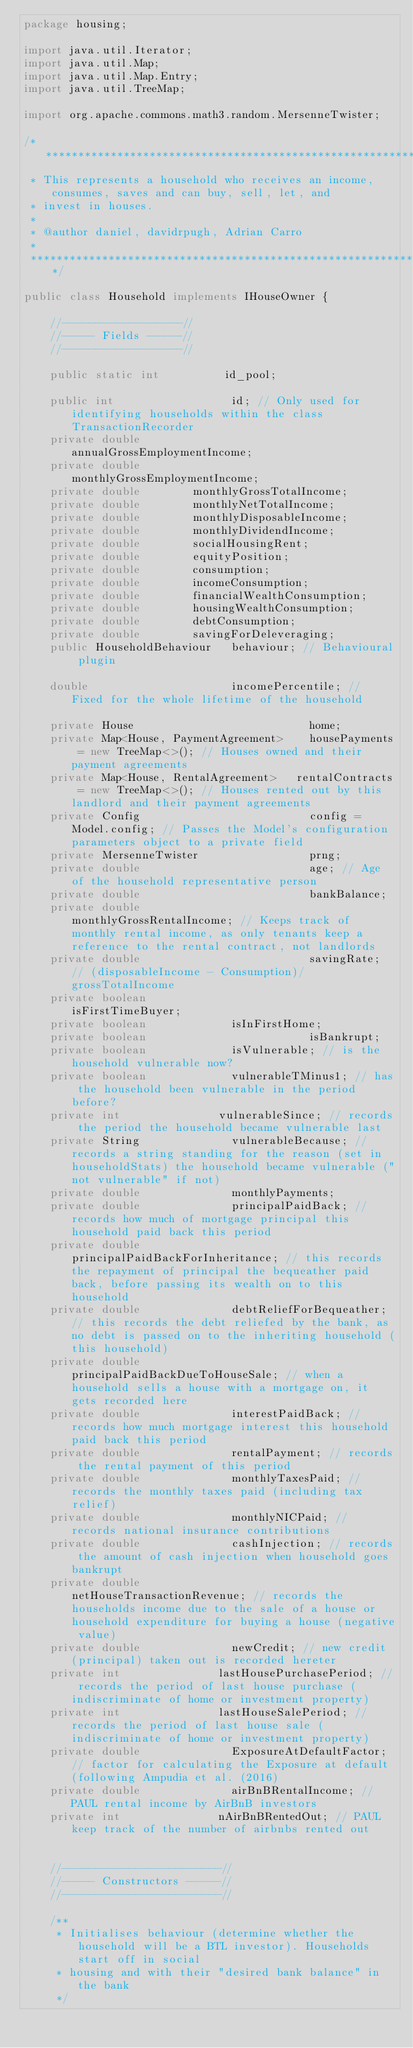<code> <loc_0><loc_0><loc_500><loc_500><_Java_>package housing;

import java.util.Iterator;
import java.util.Map;
import java.util.Map.Entry;
import java.util.TreeMap;

import org.apache.commons.math3.random.MersenneTwister;

/**************************************************************************************************
 * This represents a household who receives an income, consumes, saves and can buy, sell, let, and
 * invest in houses.
 *
 * @author daniel, davidrpugh, Adrian Carro
 *
 *************************************************************************************************/

public class Household implements IHouseOwner {

    //------------------//
    //----- Fields -----//
    //------------------//

    public static int          id_pool;

    public int                  id; // Only used for identifying households within the class TransactionRecorder
    private double              annualGrossEmploymentIncome;
    private double              monthlyGrossEmploymentIncome;
    private double				monthlyGrossTotalIncome;
    private double 				monthlyNetTotalIncome;
    private double 				monthlyDisposableIncome;
    private double 				monthlyDividendIncome;
    private double				socialHousingRent;
    private double				equityPosition;
    private double				consumption;
    private double				incomeConsumption;
    private double				financialWealthConsumption;
    private double				housingWealthConsumption;
    private double				debtConsumption;
    private double 				savingForDeleveraging;
    public HouseholdBehaviour   behaviour; // Behavioural plugin

    double                      incomePercentile; // Fixed for the whole lifetime of the household

    private House                           home;
    private Map<House, PaymentAgreement>    housePayments = new TreeMap<>(); // Houses owned and their payment agreements
    private Map<House, RentalAgreement> 	rentalContracts = new TreeMap<>(); // Houses rented out by this landlord and their payment agreements
    private Config                          config = Model.config; // Passes the Model's configuration parameters object to a private field
    private MersenneTwister                 prng;
    private double                          age; // Age of the household representative person
    private double                          bankBalance;
    private double                          monthlyGrossRentalIncome; // Keeps track of monthly rental income, as only tenants keep a reference to the rental contract, not landlords
    private double                          savingRate; // (disposableIncome - Consumption)/grossTotalIncome
    private boolean                         isFirstTimeBuyer;
    private boolean							isInFirstHome;
    private boolean                         isBankrupt;
    private boolean							isVulnerable; // is the household vulnerable now?
    private boolean							vulnerableTMinus1; // has the household been vulnerable in the period before?
    private int								vulnerableSince; // records the period the household became vulnerable last
    private String							vulnerableBecause; // records a string standing for the reason (set in householdStats) the household became vulnerable ("not vulnerable" if not)
    private double 							monthlyPayments;
    private double							principalPaidBack; // records how much of mortgage principal this household paid back this period
    private double							principalPaidBackForInheritance; // this records the repayment of principal the bequeather paid back, before passing its wealth on to this household
    private double							debtReliefForBequeather; // this records the debt reliefed by the bank, as no debt is passed on to the inheriting household (this household)
    private double							principalPaidBackDueToHouseSale; // when a household sells a house with a mortgage on, it gets recorded here
    private double							interestPaidBack; // records how much mortgage interest this household paid back this period
    private double							rentalPayment; // records the rental payment of this period
    private double							monthlyTaxesPaid; // records the monthly taxes paid (including tax relief)
    private double 							monthlyNICPaid; // records national insurance contributions
    private double 							cashInjection; // records the amount of cash injection when household goes bankrupt
    private double							netHouseTransactionRevenue; // records the households income due to the sale of a house or household expenditure for buying a house (negative value)
    private double							newCredit; // new credit (principal) taken out is recorded hereter
    private int								lastHousePurchasePeriod; // records the period of last house purchase (indiscriminate of home or investment property)
    private int								lastHouseSalePeriod; // records the period of last house sale (indiscriminate of home or investment property)
    private double							ExposureAtDefaultFactor; // factor for calculating the Exposure at default (following Ampudia et al. (2016)
    private double							airBnBRentalIncome; //PAUL rental income by AirBnB investors
    private int								nAirBnBRentedOut; // PAUL keep track of the number of airbnbs rented out
    
    
    //------------------------//
    //----- Constructors -----//
    //------------------------//

    /**
     * Initialises behaviour (determine whether the household will be a BTL investor). Households start off in social
     * housing and with their "desired bank balance" in the bank
     */</code> 